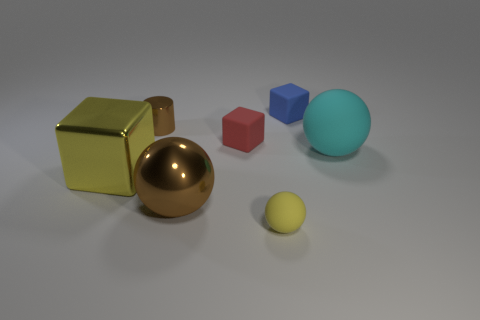Add 1 balls. How many objects exist? 8 Subtract all spheres. How many objects are left? 4 Subtract all big cyan objects. Subtract all red matte objects. How many objects are left? 5 Add 3 tiny red matte blocks. How many tiny red matte blocks are left? 4 Add 2 big metal cubes. How many big metal cubes exist? 3 Subtract 0 brown cubes. How many objects are left? 7 